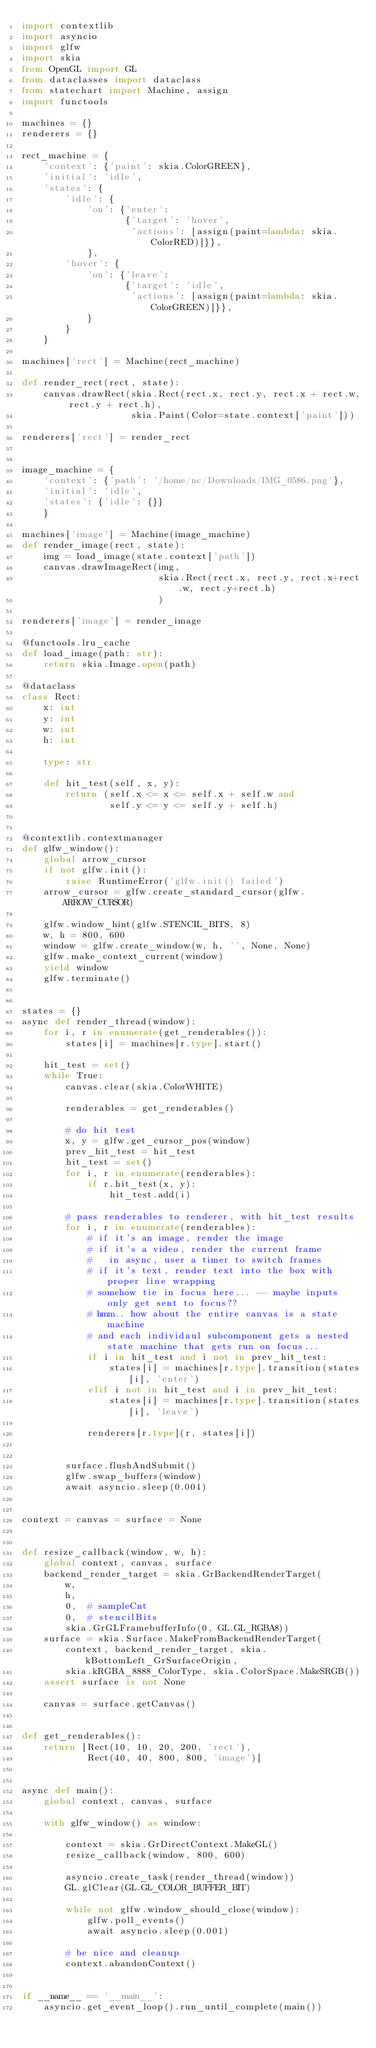<code> <loc_0><loc_0><loc_500><loc_500><_Python_>import contextlib
import asyncio
import glfw
import skia
from OpenGL import GL
from dataclasses import dataclass
from statechart import Machine, assign
import functools

machines = {}
renderers = {}

rect_machine = {
    'context': {'paint': skia.ColorGREEN},
    'initial': 'idle',
    'states': {
        'idle': {
            'on': {'enter':
                   {'target': 'hover',
                    'actions': [assign(paint=lambda: skia.ColorRED)]}},
            },
        'hover': {
            'on': {'leave':
                   {'target': 'idle',
                    'actions': [assign(paint=lambda: skia.ColorGREEN)]}},
            }
        }
    }

machines['rect'] = Machine(rect_machine)

def render_rect(rect, state):
    canvas.drawRect(skia.Rect(rect.x, rect.y, rect.x + rect.w, rect.y + rect.h),
                    skia.Paint(Color=state.context['paint']))

renderers['rect'] = render_rect


image_machine = {
    'context': {'path': '/home/nc/Downloads/IMG_0586.png'},
    'initial': 'idle',
    'states': {'idle': {}}
    }

machines['image'] = Machine(image_machine)
def render_image(rect, state):
    img = load_image(state.context['path'])
    canvas.drawImageRect(img,
                         skia.Rect(rect.x, rect.y, rect.x+rect.w, rect.y+rect.h)
                         )

renderers['image'] = render_image

@functools.lru_cache
def load_image(path: str):
    return skia.Image.open(path)

@dataclass
class Rect:
    x: int
    y: int
    w: int
    h: int

    type: str

    def hit_test(self, x, y):
        return (self.x <= x <= self.x + self.w and
                self.y <= y <= self.y + self.h)


@contextlib.contextmanager
def glfw_window():
    global arrow_cursor
    if not glfw.init():
        raise RuntimeError('glfw.init() failed')
    arrow_cursor = glfw.create_standard_cursor(glfw.ARROW_CURSOR)

    glfw.window_hint(glfw.STENCIL_BITS, 8)
    w, h = 800, 600
    window = glfw.create_window(w, h, '', None, None)
    glfw.make_context_current(window)
    yield window
    glfw.terminate()


states = {}
async def render_thread(window):
    for i, r in enumerate(get_renderables()):
        states[i] = machines[r.type].start()

    hit_test = set()
    while True:
        canvas.clear(skia.ColorWHITE)

        renderables = get_renderables()

        # do hit test
        x, y = glfw.get_cursor_pos(window)
        prev_hit_test = hit_test
        hit_test = set()
        for i, r in enumerate(renderables):
            if r.hit_test(x, y):
                hit_test.add(i)

        # pass renderables to renderer, with hit_test results
        for i, r in enumerate(renderables):
            # if it's an image, render the image
            # if it's a video, render the current frame
            #   in async, user a timer to switch frames
            # if it's text, render text into the box with proper line wrapping
            # somehow tie in focus here... -- maybe inputs only get sent to focus??
            # hmm.. how about the entire canvas is a state machine
            # and each individaul subcomponent gets a nested state machine that gets run on focus...
            if i in hit_test and i not in prev_hit_test:
                states[i] = machines[r.type].transition(states[i], 'enter')
            elif i not in hit_test and i in prev_hit_test:
                states[i] = machines[r.type].transition(states[i], 'leave')

            renderers[r.type](r, states[i])


        surface.flushAndSubmit()
        glfw.swap_buffers(window)
        await asyncio.sleep(0.001)


context = canvas = surface = None


def resize_callback(window, w, h):
    global context, canvas, surface
    backend_render_target = skia.GrBackendRenderTarget(
        w,
        h,
        0,  # sampleCnt
        0,  # stencilBits
        skia.GrGLFramebufferInfo(0, GL.GL_RGBA8))
    surface = skia.Surface.MakeFromBackendRenderTarget(
        context, backend_render_target, skia.kBottomLeft_GrSurfaceOrigin,
        skia.kRGBA_8888_ColorType, skia.ColorSpace.MakeSRGB())
    assert surface is not None

    canvas = surface.getCanvas()


def get_renderables():
    return [Rect(10, 10, 20, 200, 'rect'),
            Rect(40, 40, 800, 800, 'image')]


async def main():
    global context, canvas, surface

    with glfw_window() as window:

        context = skia.GrDirectContext.MakeGL()
        resize_callback(window, 800, 600)

        asyncio.create_task(render_thread(window))
        GL.glClear(GL.GL_COLOR_BUFFER_BIT)

        while not glfw.window_should_close(window):
            glfw.poll_events()
            await asyncio.sleep(0.001)

        # be nice and cleanup
        context.abandonContext()


if __name__ == '__main__':
    asyncio.get_event_loop().run_until_complete(main())
</code> 